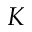<formula> <loc_0><loc_0><loc_500><loc_500>K</formula> 